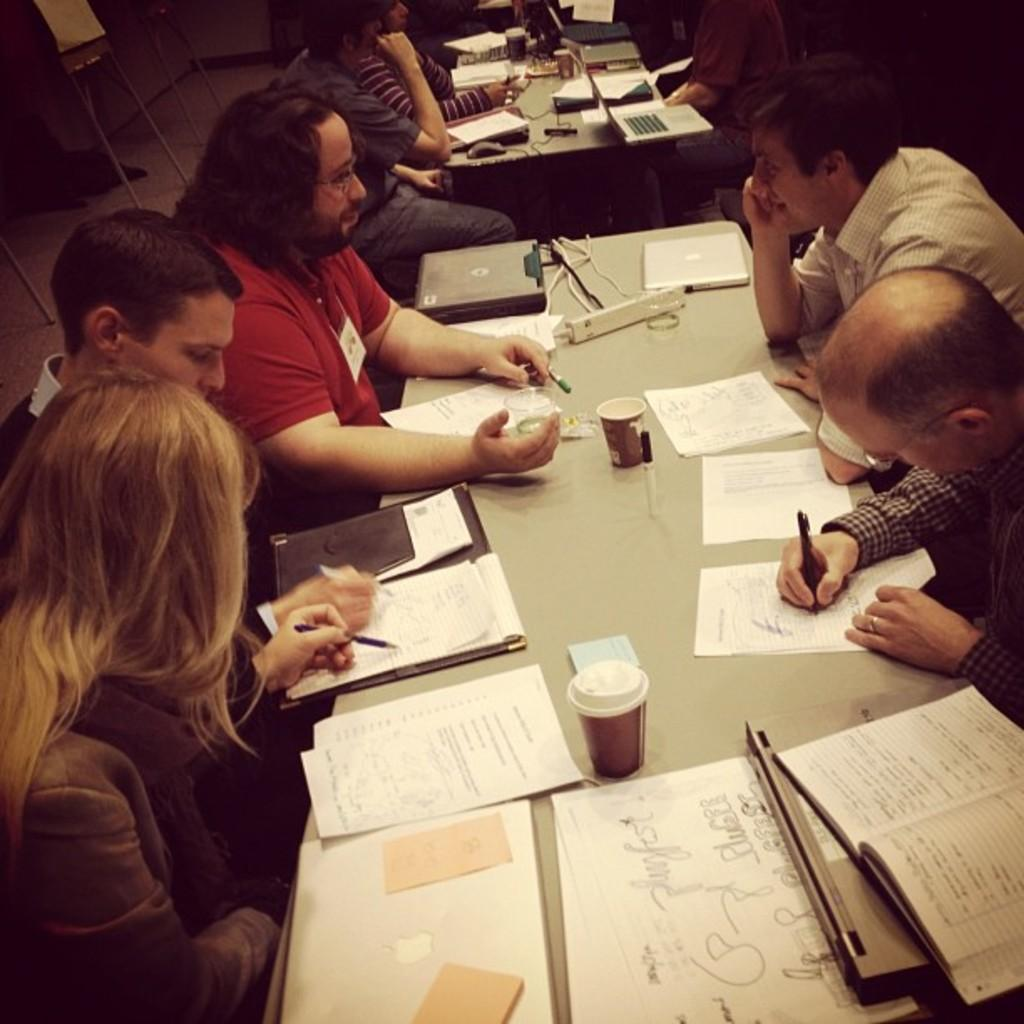How many people are in the image? There are many people in the image. What are the people doing in the image? The people are sitting on either side of a table, reading, and writing. What color is the light emitted by the slip in the image? There is no slip present in the image, and therefore no light can be emitted by it. 